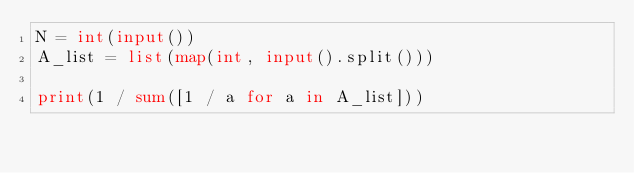<code> <loc_0><loc_0><loc_500><loc_500><_Python_>N = int(input())
A_list = list(map(int, input().split()))

print(1 / sum([1 / a for a in A_list]))
</code> 